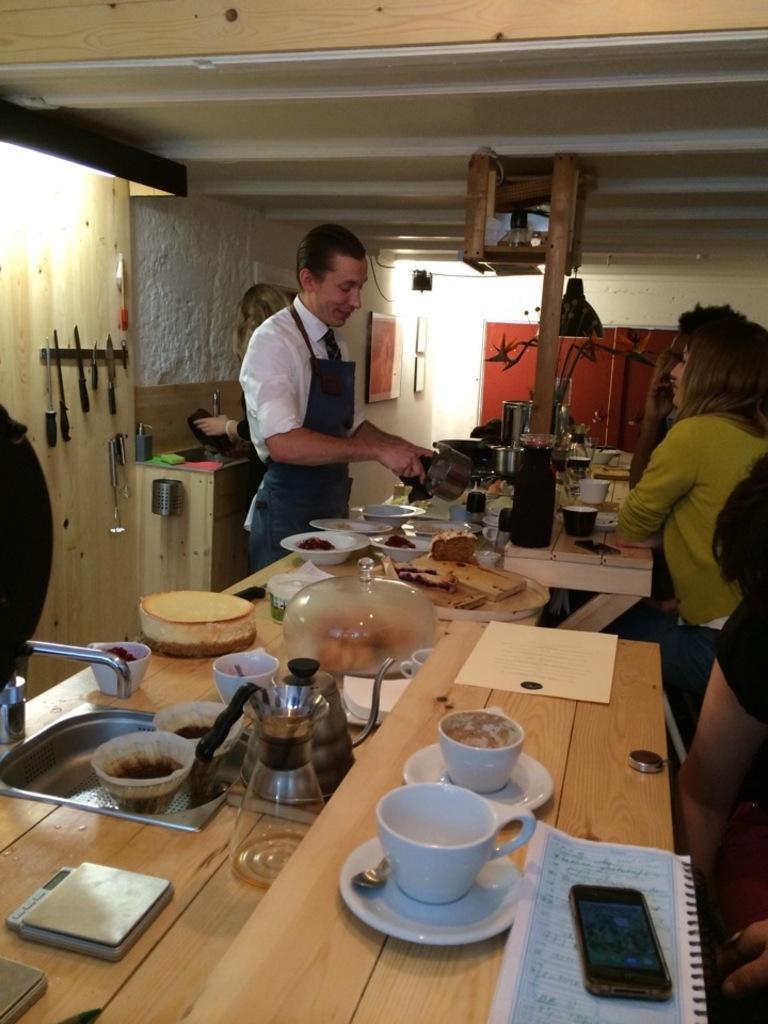Can you describe this image briefly? There are few people to the either side of this table. There are cups,mobile phone,paper,books,bowls and food items on this table. IN the background there is a wall and frames and knives on the wall. 